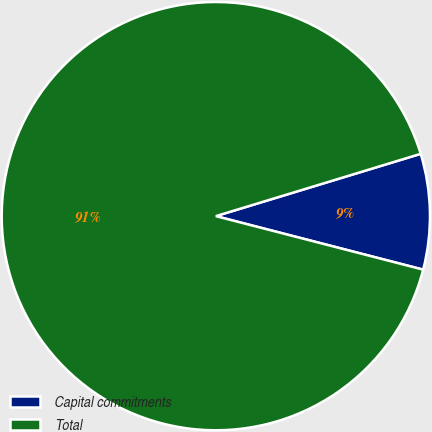<chart> <loc_0><loc_0><loc_500><loc_500><pie_chart><fcel>Capital commitments<fcel>Total<nl><fcel>8.72%<fcel>91.28%<nl></chart> 